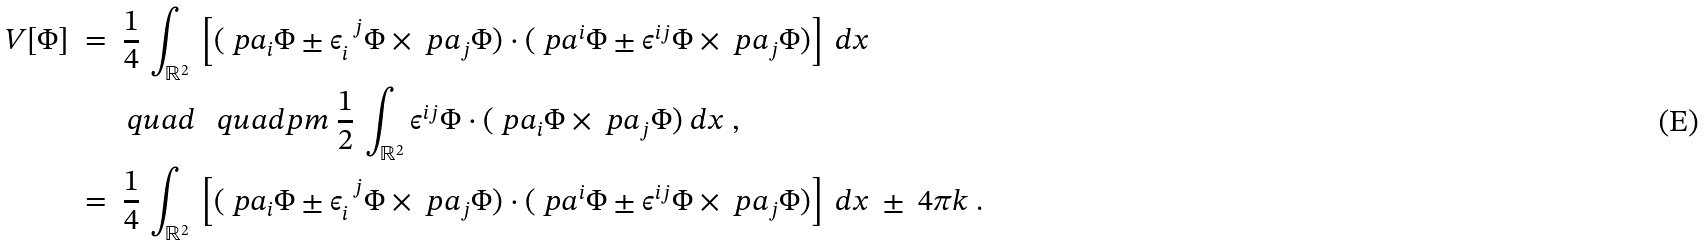<formula> <loc_0><loc_0><loc_500><loc_500>V [ \Phi ] \ & = \ \frac { 1 } { 4 } \, \int _ { \mathbb { R } ^ { 2 } } \ \left [ ( \ p a _ { i } \Phi \pm \epsilon _ { i } ^ { \ \, j } \Phi \times \ p a _ { j } \Phi ) \cdot ( \ p a ^ { i } \Phi \pm \epsilon ^ { i j } \Phi \times \ p a _ { j } \Phi ) \right ] \ d x \ \\ & \quad \ \ \ q u a d \ \ \ q u a d p m \ \frac { 1 } { 2 } \, \int _ { \mathbb { R } ^ { 2 } } \epsilon ^ { i j } \Phi \cdot ( \ p a _ { i } \Phi \times \ p a _ { j } \Phi ) \ d x \ , \\ & = \ \frac { 1 } { 4 } \, \int _ { \mathbb { R } ^ { 2 } } \ \left [ ( \ p a _ { i } \Phi \pm \epsilon _ { i } ^ { \ \, j } \Phi \times \ p a _ { j } \Phi ) \cdot ( \ p a ^ { i } \Phi \pm \epsilon ^ { i j } \Phi \times \ p a _ { j } \Phi ) \right ] \ d x \ \pm \ 4 \pi k \ .</formula> 